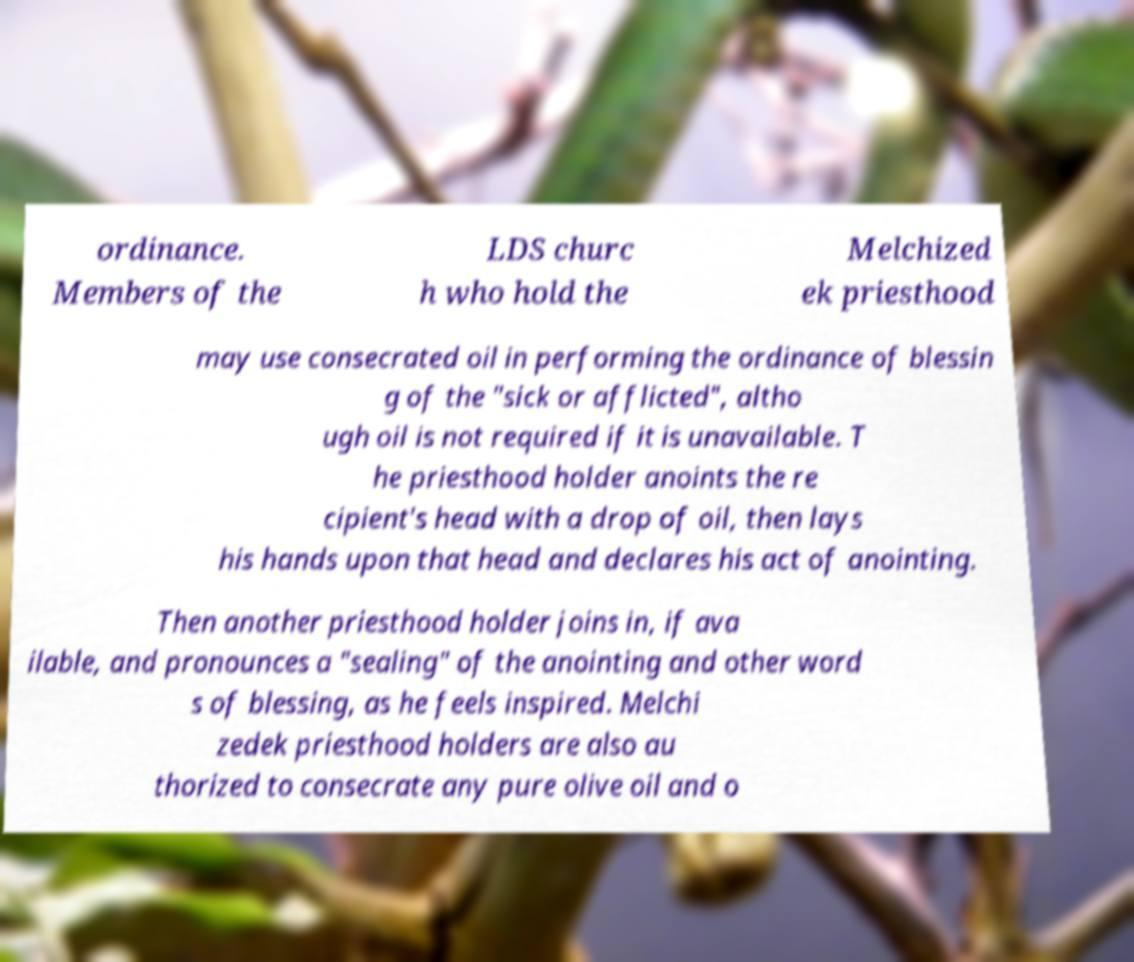Please identify and transcribe the text found in this image. ordinance. Members of the LDS churc h who hold the Melchized ek priesthood may use consecrated oil in performing the ordinance of blessin g of the "sick or afflicted", altho ugh oil is not required if it is unavailable. T he priesthood holder anoints the re cipient's head with a drop of oil, then lays his hands upon that head and declares his act of anointing. Then another priesthood holder joins in, if ava ilable, and pronounces a "sealing" of the anointing and other word s of blessing, as he feels inspired. Melchi zedek priesthood holders are also au thorized to consecrate any pure olive oil and o 